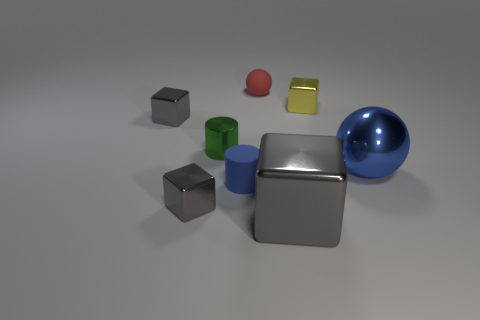Subtract all gray blocks. How many were subtracted if there are2gray blocks left? 1 Subtract all yellow metal cubes. How many cubes are left? 3 Subtract all green cylinders. How many cylinders are left? 1 Subtract all yellow cylinders. How many yellow cubes are left? 1 Add 1 large green matte cylinders. How many objects exist? 9 Subtract all spheres. How many objects are left? 6 Subtract 1 balls. How many balls are left? 1 Subtract all yellow cylinders. Subtract all purple blocks. How many cylinders are left? 2 Subtract all blocks. Subtract all small gray matte things. How many objects are left? 4 Add 1 tiny metal blocks. How many tiny metal blocks are left? 4 